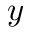<formula> <loc_0><loc_0><loc_500><loc_500>y</formula> 